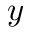<formula> <loc_0><loc_0><loc_500><loc_500>y</formula> 